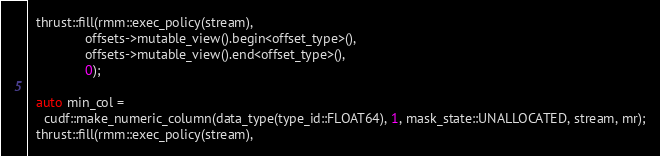<code> <loc_0><loc_0><loc_500><loc_500><_Cuda_>  thrust::fill(rmm::exec_policy(stream),
               offsets->mutable_view().begin<offset_type>(),
               offsets->mutable_view().end<offset_type>(),
               0);

  auto min_col =
    cudf::make_numeric_column(data_type(type_id::FLOAT64), 1, mask_state::UNALLOCATED, stream, mr);
  thrust::fill(rmm::exec_policy(stream),</code> 